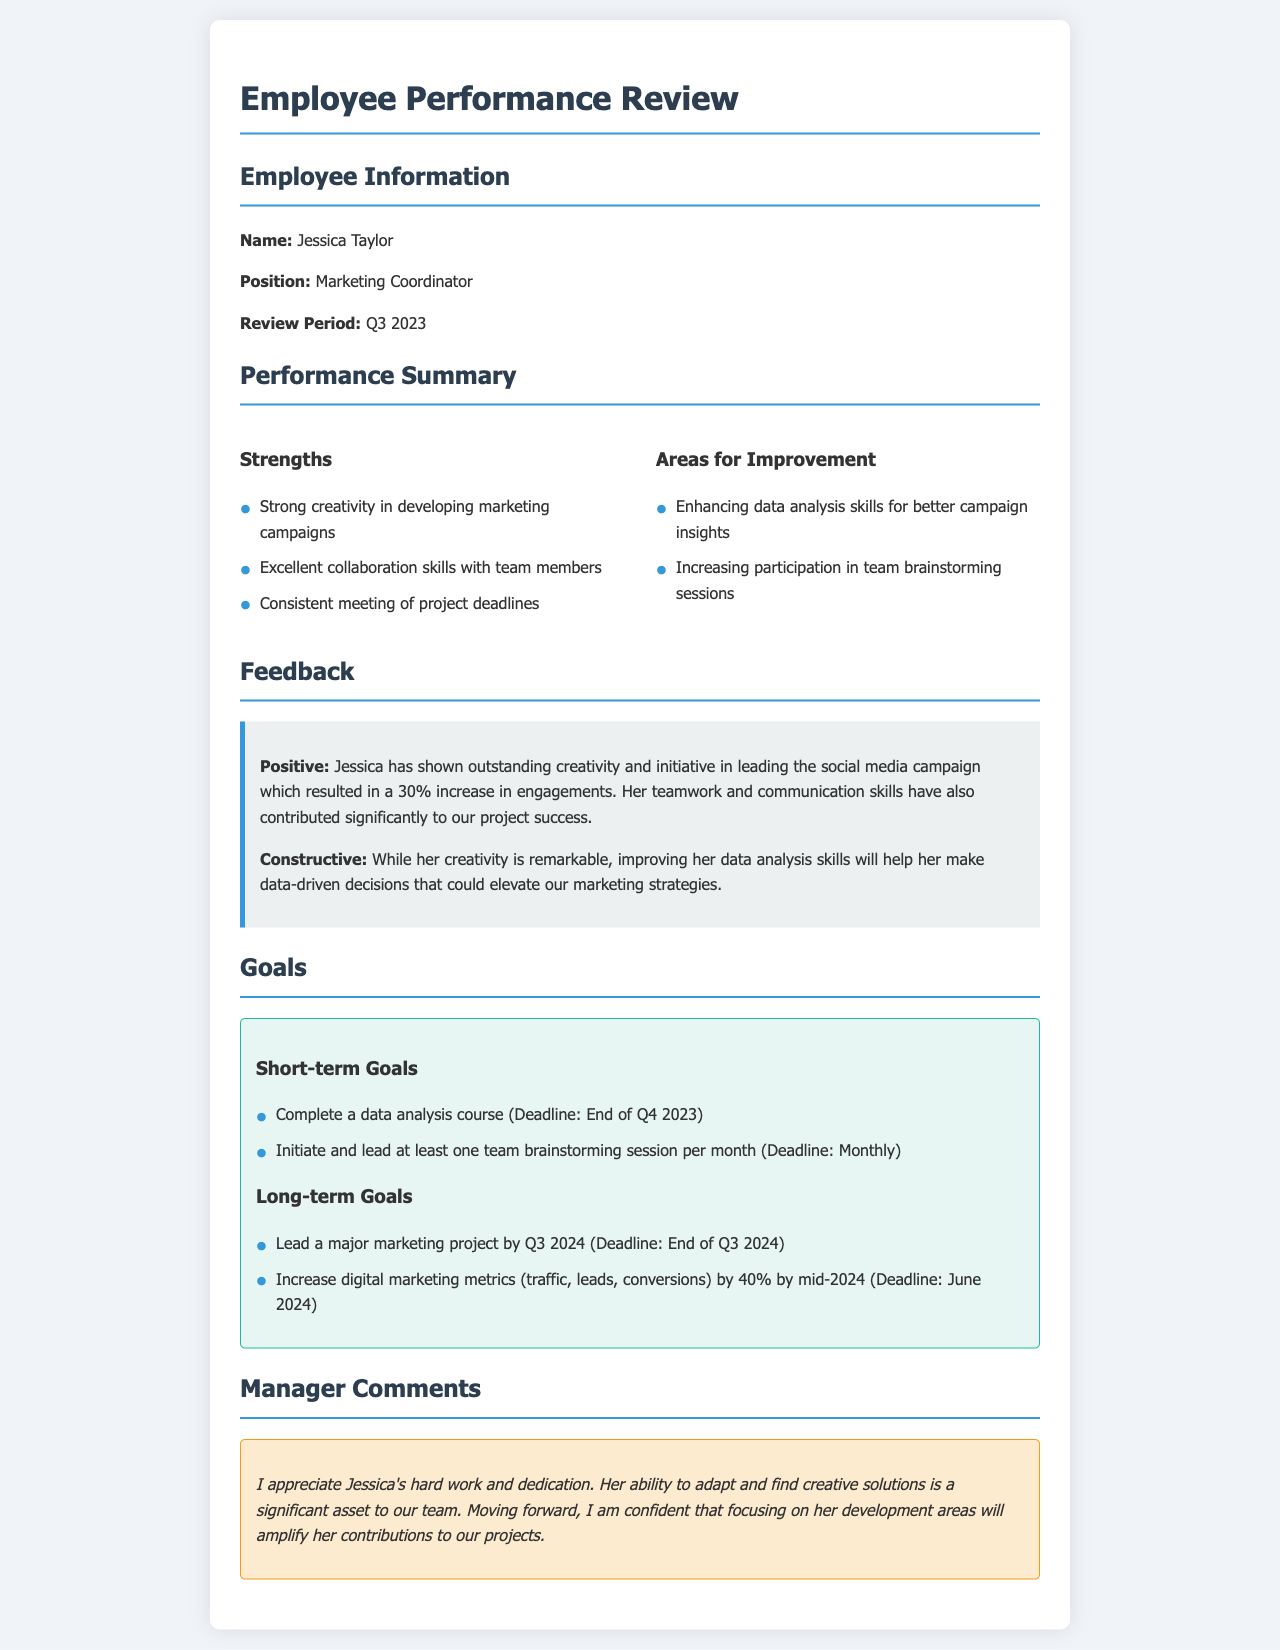What is the name of the employee? The name of the employee is stated in the Employee Information section of the document.
Answer: Jessica Taylor What position does Jessica hold? The position held by Jessica is listed under Employee Information.
Answer: Marketing Coordinator What is one of Jessica's strengths? The strengths of Jessica are presented in the Performance Summary section.
Answer: Strong creativity in developing marketing campaigns How many short-term goals are listed? The number of short-term goals can be counted in the Goals section.
Answer: Two What percentage increase in engagements resulted from the social media campaign? The percentage increase can be found in the Feedback section describing her performance.
Answer: 30% What is one area for improvement mentioned for Jessica? Areas for improvement are outlined in the Performance Summary.
Answer: Enhancing data analysis skills for better campaign insights What is the deadline for completing the data analysis course? The deadline for the listed goal is found within the Goals section.
Answer: End of Q4 2023 What is the main focus of the manager's comments? The manager's comments summarize their appreciation and observations on Jessica's performance.
Answer: Hard work and dedication How many long-term goals are specified? The long-term goals are counted in the Goals section of the document.
Answer: Two 